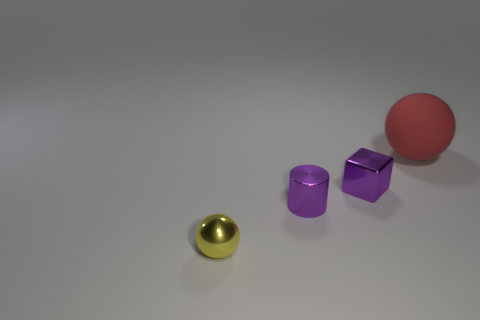What objects are shown in this image? The image displays three objects on a neutral surface: a golden-colored, metallic, reflective hemisphere; a matte purple cube; and a translucent pink sphere with a slightly reflective surface. 